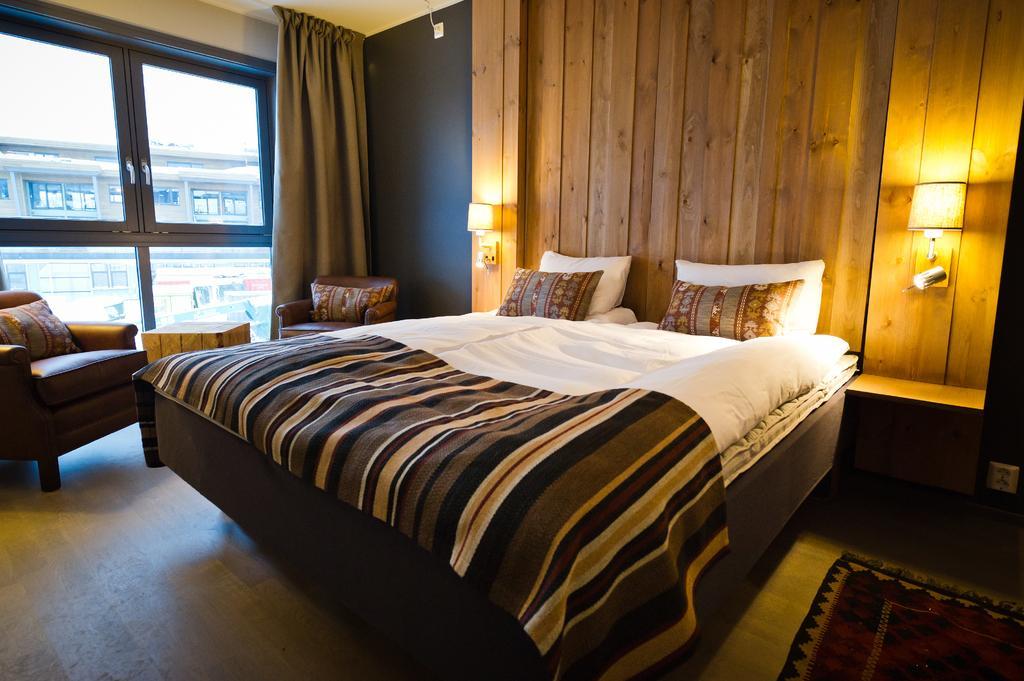In one or two sentences, can you explain what this image depicts? In this picture we can see a bed in the room. And these are the chairs. On the background there is a wall. And this is the lamp. Here we can see a building from the window. And this is the curtain. 